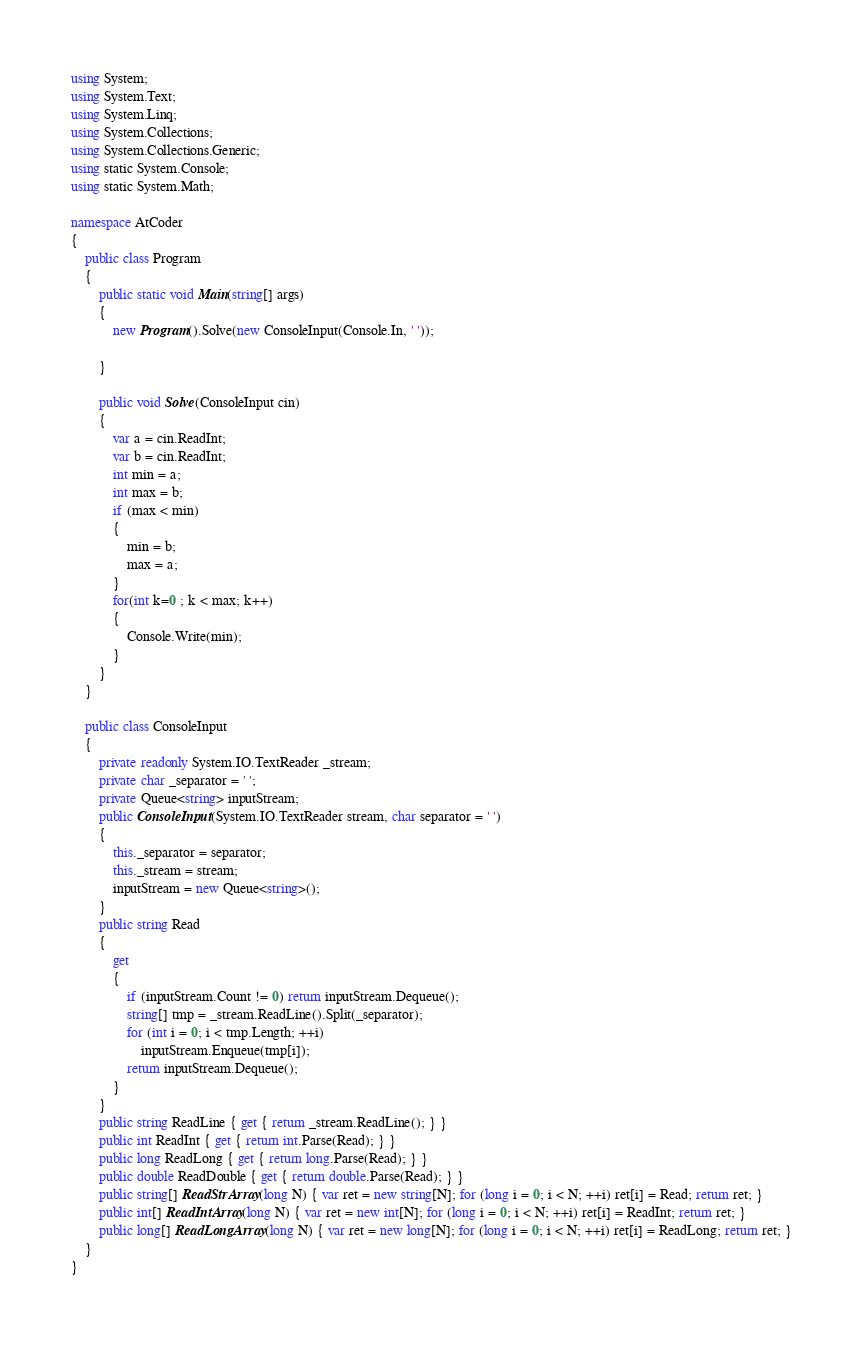<code> <loc_0><loc_0><loc_500><loc_500><_C#_>using System;
using System.Text;
using System.Linq;
using System.Collections;
using System.Collections.Generic;
using static System.Console;
using static System.Math;

namespace AtCoder
{
    public class Program
    {
        public static void Main(string[] args)
        {
            new Program().Solve(new ConsoleInput(Console.In, ' '));

        }

        public void Solve(ConsoleInput cin)
        {
            var a = cin.ReadInt;
            var b = cin.ReadInt;
            int min = a;
            int max = b;
            if (max < min)
            {
                min = b;
                max = a;
            }
            for(int k=0 ; k < max; k++)
            {
                Console.Write(min);
            }
        }
    }

    public class ConsoleInput
    {
        private readonly System.IO.TextReader _stream;
        private char _separator = ' ';
        private Queue<string> inputStream;
        public ConsoleInput(System.IO.TextReader stream, char separator = ' ')
        {
            this._separator = separator;
            this._stream = stream;
            inputStream = new Queue<string>();
        }
        public string Read
        {
            get
            {
                if (inputStream.Count != 0) return inputStream.Dequeue();
                string[] tmp = _stream.ReadLine().Split(_separator);
                for (int i = 0; i < tmp.Length; ++i)
                    inputStream.Enqueue(tmp[i]);
                return inputStream.Dequeue();
            }
        }
        public string ReadLine { get { return _stream.ReadLine(); } }
        public int ReadInt { get { return int.Parse(Read); } }
        public long ReadLong { get { return long.Parse(Read); } }
        public double ReadDouble { get { return double.Parse(Read); } }
        public string[] ReadStrArray(long N) { var ret = new string[N]; for (long i = 0; i < N; ++i) ret[i] = Read; return ret; }
        public int[] ReadIntArray(long N) { var ret = new int[N]; for (long i = 0; i < N; ++i) ret[i] = ReadInt; return ret; }
        public long[] ReadLongArray(long N) { var ret = new long[N]; for (long i = 0; i < N; ++i) ret[i] = ReadLong; return ret; }
    }
}</code> 